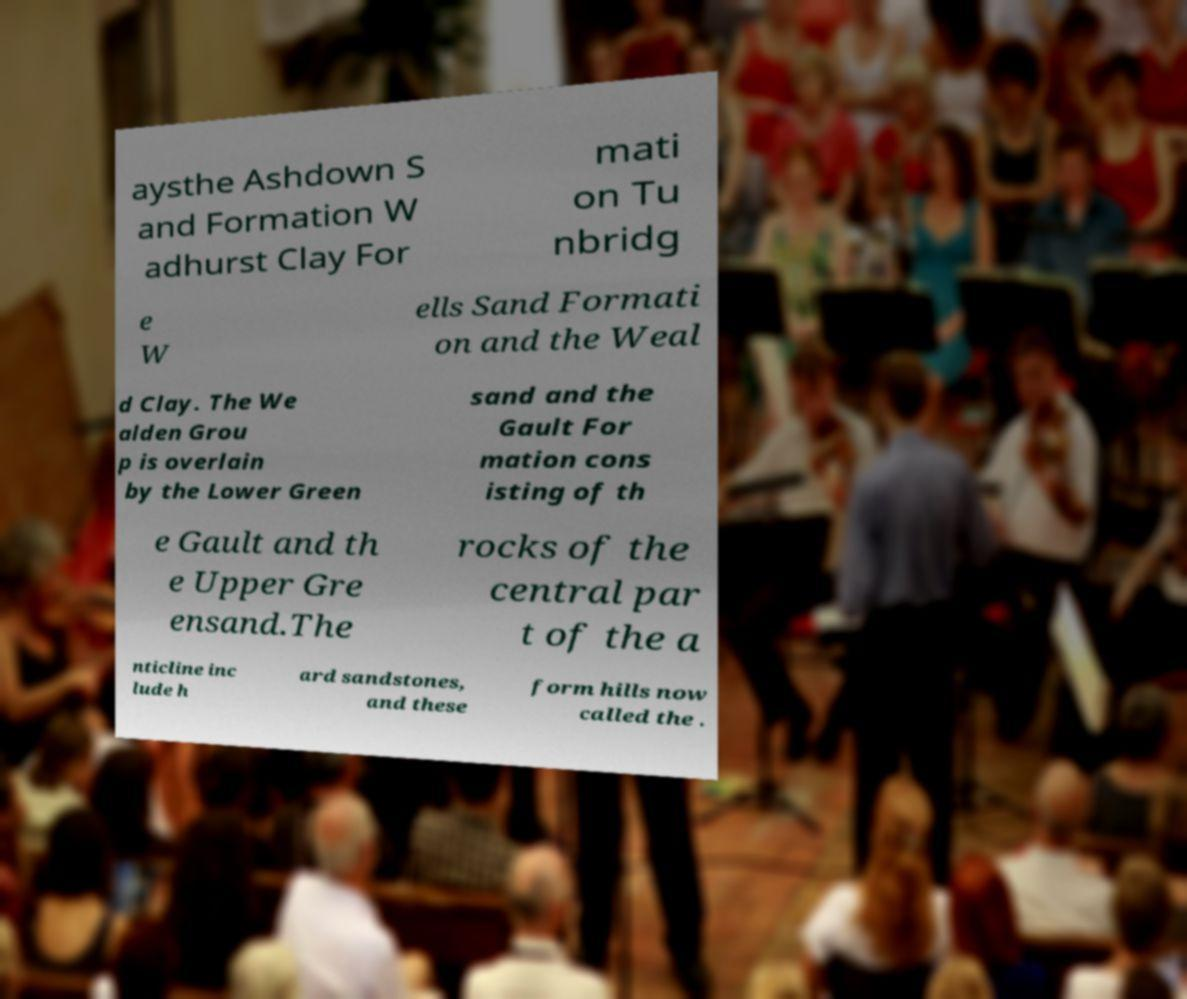Can you accurately transcribe the text from the provided image for me? aysthe Ashdown S and Formation W adhurst Clay For mati on Tu nbridg e W ells Sand Formati on and the Weal d Clay. The We alden Grou p is overlain by the Lower Green sand and the Gault For mation cons isting of th e Gault and th e Upper Gre ensand.The rocks of the central par t of the a nticline inc lude h ard sandstones, and these form hills now called the . 